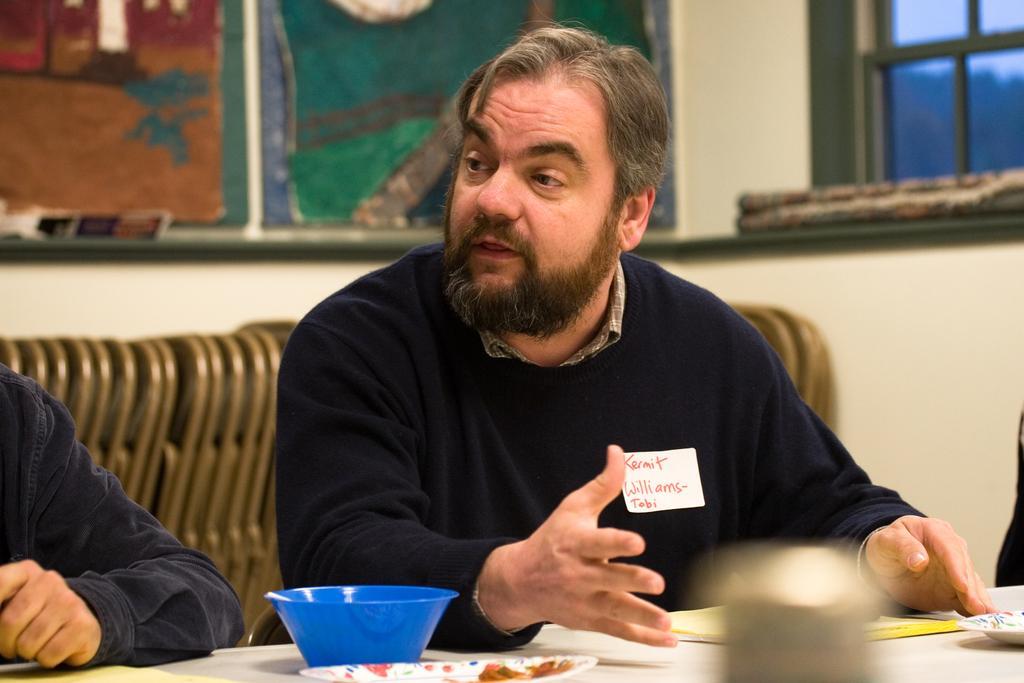How would you summarize this image in a sentence or two? In this picture there is a man sitting on the chair. There is a bowl, plate and book. There is also another person. 